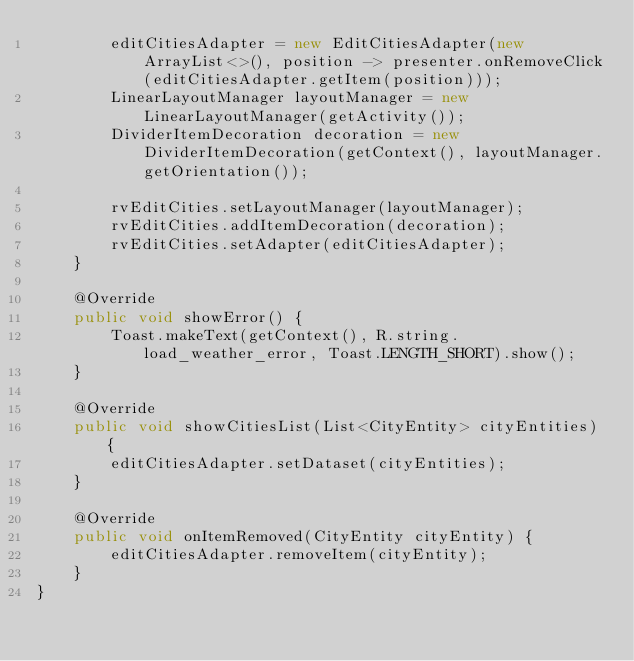Convert code to text. <code><loc_0><loc_0><loc_500><loc_500><_Java_>        editCitiesAdapter = new EditCitiesAdapter(new ArrayList<>(), position -> presenter.onRemoveClick(editCitiesAdapter.getItem(position)));
        LinearLayoutManager layoutManager = new LinearLayoutManager(getActivity());
        DividerItemDecoration decoration = new DividerItemDecoration(getContext(), layoutManager.getOrientation());

        rvEditCities.setLayoutManager(layoutManager);
        rvEditCities.addItemDecoration(decoration);
        rvEditCities.setAdapter(editCitiesAdapter);
    }

    @Override
    public void showError() {
        Toast.makeText(getContext(), R.string.load_weather_error, Toast.LENGTH_SHORT).show();
    }

    @Override
    public void showCitiesList(List<CityEntity> cityEntities) {
        editCitiesAdapter.setDataset(cityEntities);
    }

    @Override
    public void onItemRemoved(CityEntity cityEntity) {
        editCitiesAdapter.removeItem(cityEntity);
    }
}
</code> 